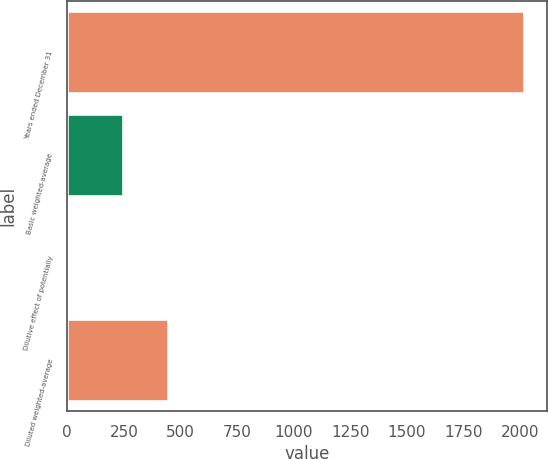Convert chart to OTSL. <chart><loc_0><loc_0><loc_500><loc_500><bar_chart><fcel>Years ended December 31<fcel>Basic weighted-average<fcel>Dilutive effect of potentially<fcel>Diluted weighted-average<nl><fcel>2018<fcel>245.2<fcel>1.8<fcel>446.82<nl></chart> 